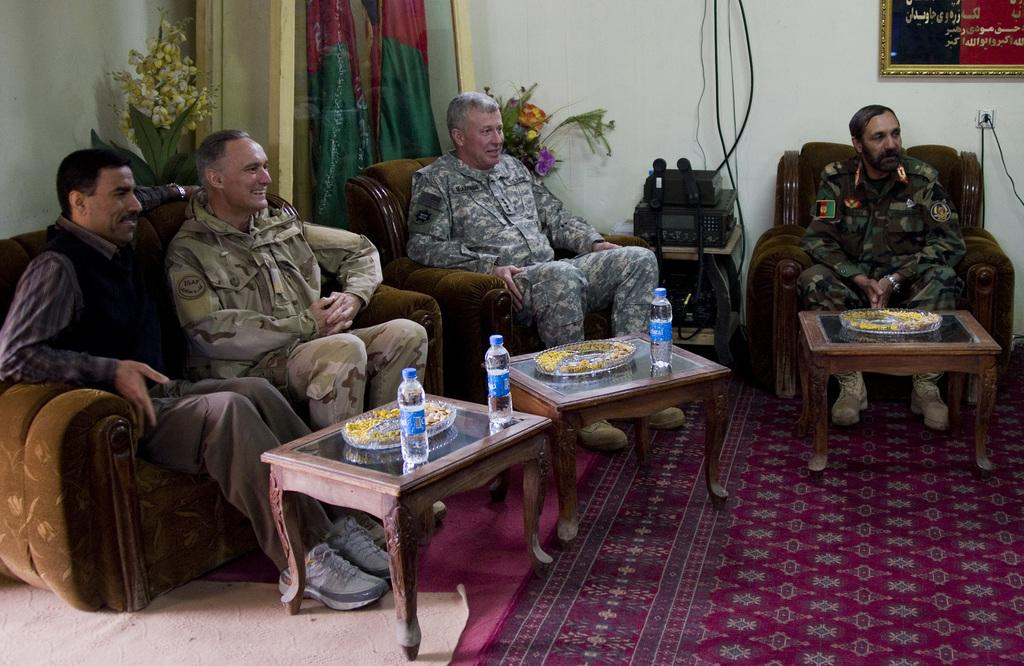How many tables are present in the image? There are three tables in the image. What is on each of the tables? Each table has a tray on it. What can be seen on the trays? There are water bottles on the tables. How many people are in the image? There are four people in the image. What is visible in the background? There is a flower pot and flags in the background. Can you tell me how many bubbles are floating around the tables in the image? There are no bubbles present in the image. What type of milk is being served to the people in the image? There is no milk present in the image; only water bottles are visible. 